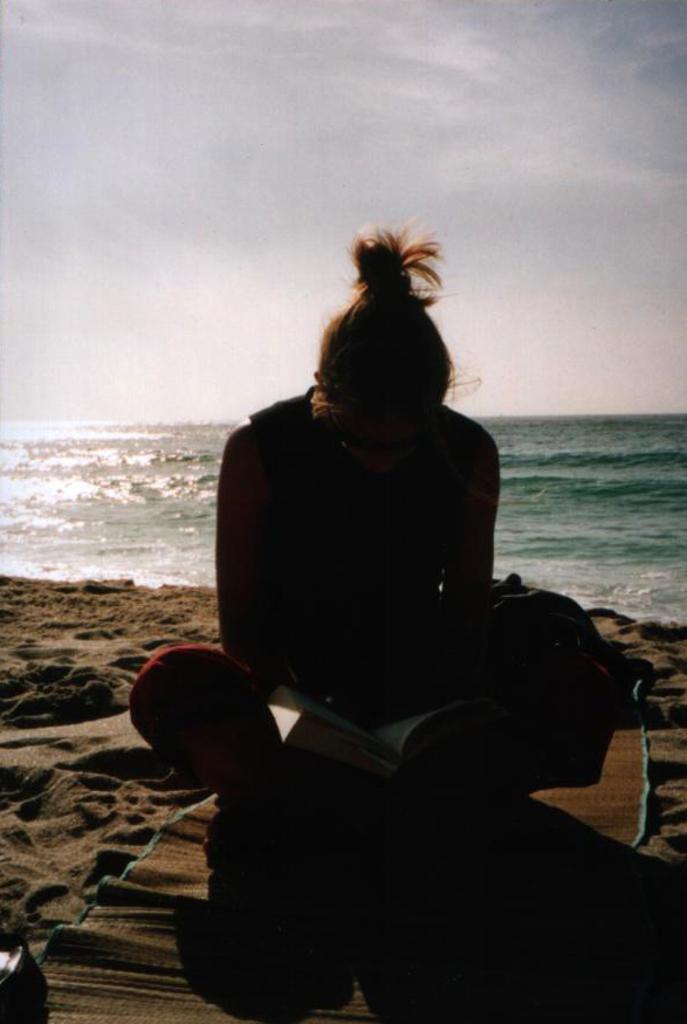In one or two sentences, can you explain what this image depicts? In this image I can see a person is sitting. I can also see a mattress, a book, sand and in the background I can see water, clouds and the sky. I can see this image is little bit in dark from here. 